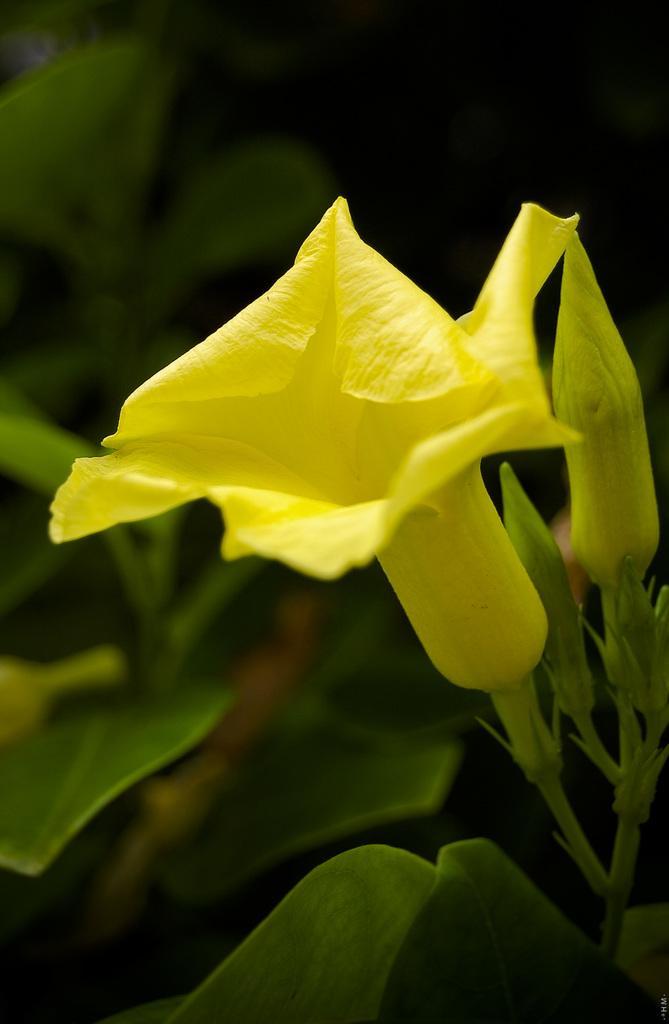Can you describe this image briefly? This picture contains flower which is yellow in color. Behind that, there are buds in yellow and green color. In the background, it is green in color and it is blurred in the background. 